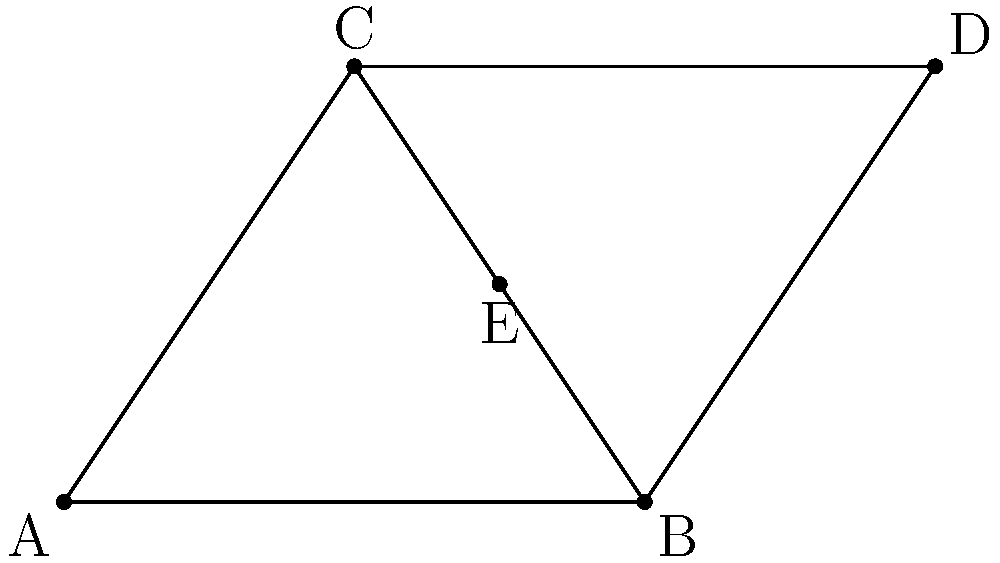As an environmentally-conscious race venue overseer, you're reviewing designs for eco-friendly tents. The diagram shows a cross-section of two adjacent tents. If $\triangle ABC \cong \triangle BCD$, what is the length of BE? To find the length of BE, we can follow these steps:

1) Since $\triangle ABC \cong \triangle BCD$, we know that:
   - AB = BC (side)
   - $\angle BAC = \angle BCD$ (angle)
   - AC = CD (side)

2) Point E is the midpoint of AC, as it's the peak of the tent structure.

3) In $\triangle ABC$:
   - BE is the median to side AC
   - BE is also the altitude (height) of the tent

4) In congruent triangles, corresponding medians are equal.
   So, BE in $\triangle ABC$ = CE in $\triangle BCD$

5) Since E is the midpoint of AC, AE = EC = 1/2 AC

6) In $\triangle ABC$, we can use the Pythagorean theorem:
   $AB^2 = AE^2 + BE^2$

7) We're given that AB = 4 (from the diagram), and we know AE = 1/2 AC = 1.5

8) Substituting into the Pythagorean theorem:
   $4^2 = 1.5^2 + BE^2$
   $16 = 2.25 + BE^2$
   $BE^2 = 13.75$
   $BE = \sqrt{13.75} = 3.708$

Therefore, the length of BE is approximately 3.708 units.
Answer: $\sqrt{13.75}$ or approximately 3.708 units 